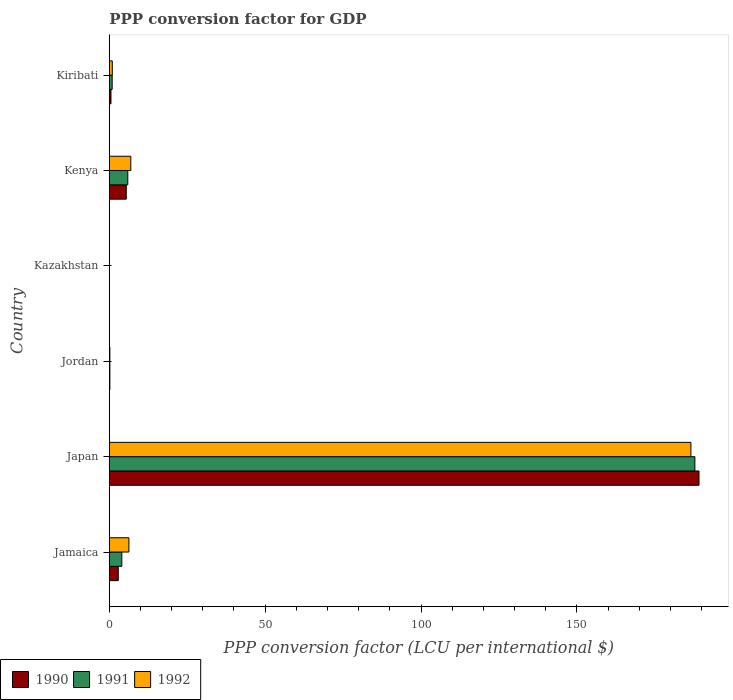How many different coloured bars are there?
Give a very brief answer. 3. How many groups of bars are there?
Provide a short and direct response. 6. Are the number of bars per tick equal to the number of legend labels?
Give a very brief answer. Yes. How many bars are there on the 3rd tick from the top?
Your response must be concise. 3. How many bars are there on the 2nd tick from the bottom?
Make the answer very short. 3. What is the label of the 4th group of bars from the top?
Your answer should be very brief. Jordan. In how many cases, is the number of bars for a given country not equal to the number of legend labels?
Offer a very short reply. 0. What is the PPP conversion factor for GDP in 1990 in Jamaica?
Give a very brief answer. 2.89. Across all countries, what is the maximum PPP conversion factor for GDP in 1990?
Your answer should be compact. 189.17. Across all countries, what is the minimum PPP conversion factor for GDP in 1990?
Make the answer very short. 0. In which country was the PPP conversion factor for GDP in 1992 minimum?
Keep it short and to the point. Kazakhstan. What is the total PPP conversion factor for GDP in 1990 in the graph?
Provide a succinct answer. 198.26. What is the difference between the PPP conversion factor for GDP in 1992 in Kazakhstan and that in Kenya?
Provide a succinct answer. -6.89. What is the difference between the PPP conversion factor for GDP in 1991 in Japan and the PPP conversion factor for GDP in 1992 in Kazakhstan?
Provide a short and direct response. 187.83. What is the average PPP conversion factor for GDP in 1990 per country?
Keep it short and to the point. 33.04. What is the difference between the PPP conversion factor for GDP in 1992 and PPP conversion factor for GDP in 1991 in Jordan?
Provide a short and direct response. 0. What is the ratio of the PPP conversion factor for GDP in 1992 in Jamaica to that in Kenya?
Offer a very short reply. 0.91. What is the difference between the highest and the second highest PPP conversion factor for GDP in 1991?
Keep it short and to the point. 181.91. What is the difference between the highest and the lowest PPP conversion factor for GDP in 1992?
Provide a short and direct response. 186.56. In how many countries, is the PPP conversion factor for GDP in 1991 greater than the average PPP conversion factor for GDP in 1991 taken over all countries?
Your answer should be very brief. 1. Is the sum of the PPP conversion factor for GDP in 1990 in Kazakhstan and Kenya greater than the maximum PPP conversion factor for GDP in 1991 across all countries?
Keep it short and to the point. No. What does the 3rd bar from the top in Kazakhstan represents?
Provide a short and direct response. 1990. What does the 2nd bar from the bottom in Japan represents?
Provide a short and direct response. 1991. How many bars are there?
Give a very brief answer. 18. What is the difference between two consecutive major ticks on the X-axis?
Keep it short and to the point. 50. Are the values on the major ticks of X-axis written in scientific E-notation?
Give a very brief answer. No. Does the graph contain any zero values?
Make the answer very short. No. Does the graph contain grids?
Ensure brevity in your answer.  No. How many legend labels are there?
Provide a succinct answer. 3. What is the title of the graph?
Provide a succinct answer. PPP conversion factor for GDP. Does "1984" appear as one of the legend labels in the graph?
Ensure brevity in your answer.  No. What is the label or title of the X-axis?
Keep it short and to the point. PPP conversion factor (LCU per international $). What is the PPP conversion factor (LCU per international $) of 1990 in Jamaica?
Your response must be concise. 2.89. What is the PPP conversion factor (LCU per international $) of 1991 in Jamaica?
Your answer should be compact. 4.02. What is the PPP conversion factor (LCU per international $) of 1992 in Jamaica?
Make the answer very short. 6.3. What is the PPP conversion factor (LCU per international $) of 1990 in Japan?
Offer a very short reply. 189.17. What is the PPP conversion factor (LCU per international $) in 1991 in Japan?
Give a very brief answer. 187.85. What is the PPP conversion factor (LCU per international $) in 1992 in Japan?
Offer a very short reply. 186.58. What is the PPP conversion factor (LCU per international $) of 1990 in Jordan?
Give a very brief answer. 0.19. What is the PPP conversion factor (LCU per international $) of 1991 in Jordan?
Offer a terse response. 0.19. What is the PPP conversion factor (LCU per international $) in 1992 in Jordan?
Your answer should be very brief. 0.2. What is the PPP conversion factor (LCU per international $) in 1990 in Kazakhstan?
Offer a very short reply. 0. What is the PPP conversion factor (LCU per international $) in 1991 in Kazakhstan?
Offer a very short reply. 0. What is the PPP conversion factor (LCU per international $) of 1992 in Kazakhstan?
Provide a short and direct response. 0.02. What is the PPP conversion factor (LCU per international $) in 1990 in Kenya?
Ensure brevity in your answer.  5.46. What is the PPP conversion factor (LCU per international $) in 1991 in Kenya?
Provide a short and direct response. 5.94. What is the PPP conversion factor (LCU per international $) of 1992 in Kenya?
Offer a terse response. 6.91. What is the PPP conversion factor (LCU per international $) of 1990 in Kiribati?
Provide a succinct answer. 0.55. What is the PPP conversion factor (LCU per international $) in 1991 in Kiribati?
Your response must be concise. 0.93. What is the PPP conversion factor (LCU per international $) in 1992 in Kiribati?
Give a very brief answer. 0.97. Across all countries, what is the maximum PPP conversion factor (LCU per international $) in 1990?
Provide a short and direct response. 189.17. Across all countries, what is the maximum PPP conversion factor (LCU per international $) of 1991?
Make the answer very short. 187.85. Across all countries, what is the maximum PPP conversion factor (LCU per international $) in 1992?
Make the answer very short. 186.58. Across all countries, what is the minimum PPP conversion factor (LCU per international $) in 1990?
Your response must be concise. 0. Across all countries, what is the minimum PPP conversion factor (LCU per international $) of 1991?
Give a very brief answer. 0. Across all countries, what is the minimum PPP conversion factor (LCU per international $) of 1992?
Offer a terse response. 0.02. What is the total PPP conversion factor (LCU per international $) of 1990 in the graph?
Keep it short and to the point. 198.26. What is the total PPP conversion factor (LCU per international $) of 1991 in the graph?
Your response must be concise. 198.94. What is the total PPP conversion factor (LCU per international $) of 1992 in the graph?
Provide a succinct answer. 200.97. What is the difference between the PPP conversion factor (LCU per international $) of 1990 in Jamaica and that in Japan?
Provide a short and direct response. -186.28. What is the difference between the PPP conversion factor (LCU per international $) in 1991 in Jamaica and that in Japan?
Provide a short and direct response. -183.82. What is the difference between the PPP conversion factor (LCU per international $) in 1992 in Jamaica and that in Japan?
Your answer should be very brief. -180.28. What is the difference between the PPP conversion factor (LCU per international $) of 1990 in Jamaica and that in Jordan?
Your answer should be compact. 2.7. What is the difference between the PPP conversion factor (LCU per international $) of 1991 in Jamaica and that in Jordan?
Give a very brief answer. 3.83. What is the difference between the PPP conversion factor (LCU per international $) of 1992 in Jamaica and that in Jordan?
Make the answer very short. 6.1. What is the difference between the PPP conversion factor (LCU per international $) in 1990 in Jamaica and that in Kazakhstan?
Keep it short and to the point. 2.89. What is the difference between the PPP conversion factor (LCU per international $) in 1991 in Jamaica and that in Kazakhstan?
Your answer should be compact. 4.02. What is the difference between the PPP conversion factor (LCU per international $) of 1992 in Jamaica and that in Kazakhstan?
Offer a terse response. 6.28. What is the difference between the PPP conversion factor (LCU per international $) in 1990 in Jamaica and that in Kenya?
Provide a short and direct response. -2.56. What is the difference between the PPP conversion factor (LCU per international $) of 1991 in Jamaica and that in Kenya?
Make the answer very short. -1.92. What is the difference between the PPP conversion factor (LCU per international $) in 1992 in Jamaica and that in Kenya?
Keep it short and to the point. -0.61. What is the difference between the PPP conversion factor (LCU per international $) in 1990 in Jamaica and that in Kiribati?
Make the answer very short. 2.35. What is the difference between the PPP conversion factor (LCU per international $) in 1991 in Jamaica and that in Kiribati?
Provide a succinct answer. 3.09. What is the difference between the PPP conversion factor (LCU per international $) in 1992 in Jamaica and that in Kiribati?
Offer a terse response. 5.33. What is the difference between the PPP conversion factor (LCU per international $) in 1990 in Japan and that in Jordan?
Your answer should be compact. 188.98. What is the difference between the PPP conversion factor (LCU per international $) of 1991 in Japan and that in Jordan?
Offer a very short reply. 187.65. What is the difference between the PPP conversion factor (LCU per international $) of 1992 in Japan and that in Jordan?
Make the answer very short. 186.38. What is the difference between the PPP conversion factor (LCU per international $) in 1990 in Japan and that in Kazakhstan?
Make the answer very short. 189.17. What is the difference between the PPP conversion factor (LCU per international $) in 1991 in Japan and that in Kazakhstan?
Your answer should be very brief. 187.85. What is the difference between the PPP conversion factor (LCU per international $) in 1992 in Japan and that in Kazakhstan?
Provide a short and direct response. 186.56. What is the difference between the PPP conversion factor (LCU per international $) in 1990 in Japan and that in Kenya?
Make the answer very short. 183.72. What is the difference between the PPP conversion factor (LCU per international $) of 1991 in Japan and that in Kenya?
Provide a succinct answer. 181.91. What is the difference between the PPP conversion factor (LCU per international $) of 1992 in Japan and that in Kenya?
Offer a very short reply. 179.67. What is the difference between the PPP conversion factor (LCU per international $) in 1990 in Japan and that in Kiribati?
Your response must be concise. 188.63. What is the difference between the PPP conversion factor (LCU per international $) of 1991 in Japan and that in Kiribati?
Offer a terse response. 186.92. What is the difference between the PPP conversion factor (LCU per international $) of 1992 in Japan and that in Kiribati?
Ensure brevity in your answer.  185.61. What is the difference between the PPP conversion factor (LCU per international $) in 1990 in Jordan and that in Kazakhstan?
Your response must be concise. 0.19. What is the difference between the PPP conversion factor (LCU per international $) of 1991 in Jordan and that in Kazakhstan?
Give a very brief answer. 0.19. What is the difference between the PPP conversion factor (LCU per international $) of 1992 in Jordan and that in Kazakhstan?
Provide a short and direct response. 0.18. What is the difference between the PPP conversion factor (LCU per international $) of 1990 in Jordan and that in Kenya?
Offer a terse response. -5.26. What is the difference between the PPP conversion factor (LCU per international $) of 1991 in Jordan and that in Kenya?
Give a very brief answer. -5.75. What is the difference between the PPP conversion factor (LCU per international $) in 1992 in Jordan and that in Kenya?
Your response must be concise. -6.71. What is the difference between the PPP conversion factor (LCU per international $) of 1990 in Jordan and that in Kiribati?
Give a very brief answer. -0.35. What is the difference between the PPP conversion factor (LCU per international $) in 1991 in Jordan and that in Kiribati?
Give a very brief answer. -0.74. What is the difference between the PPP conversion factor (LCU per international $) in 1992 in Jordan and that in Kiribati?
Offer a very short reply. -0.78. What is the difference between the PPP conversion factor (LCU per international $) of 1990 in Kazakhstan and that in Kenya?
Provide a succinct answer. -5.45. What is the difference between the PPP conversion factor (LCU per international $) in 1991 in Kazakhstan and that in Kenya?
Provide a succinct answer. -5.94. What is the difference between the PPP conversion factor (LCU per international $) of 1992 in Kazakhstan and that in Kenya?
Keep it short and to the point. -6.89. What is the difference between the PPP conversion factor (LCU per international $) of 1990 in Kazakhstan and that in Kiribati?
Give a very brief answer. -0.54. What is the difference between the PPP conversion factor (LCU per international $) of 1991 in Kazakhstan and that in Kiribati?
Your response must be concise. -0.93. What is the difference between the PPP conversion factor (LCU per international $) in 1992 in Kazakhstan and that in Kiribati?
Give a very brief answer. -0.95. What is the difference between the PPP conversion factor (LCU per international $) of 1990 in Kenya and that in Kiribati?
Your answer should be very brief. 4.91. What is the difference between the PPP conversion factor (LCU per international $) in 1991 in Kenya and that in Kiribati?
Provide a succinct answer. 5.01. What is the difference between the PPP conversion factor (LCU per international $) of 1992 in Kenya and that in Kiribati?
Provide a short and direct response. 5.93. What is the difference between the PPP conversion factor (LCU per international $) of 1990 in Jamaica and the PPP conversion factor (LCU per international $) of 1991 in Japan?
Your answer should be very brief. -184.96. What is the difference between the PPP conversion factor (LCU per international $) of 1990 in Jamaica and the PPP conversion factor (LCU per international $) of 1992 in Japan?
Keep it short and to the point. -183.69. What is the difference between the PPP conversion factor (LCU per international $) in 1991 in Jamaica and the PPP conversion factor (LCU per international $) in 1992 in Japan?
Offer a terse response. -182.55. What is the difference between the PPP conversion factor (LCU per international $) of 1990 in Jamaica and the PPP conversion factor (LCU per international $) of 1991 in Jordan?
Provide a succinct answer. 2.7. What is the difference between the PPP conversion factor (LCU per international $) of 1990 in Jamaica and the PPP conversion factor (LCU per international $) of 1992 in Jordan?
Give a very brief answer. 2.7. What is the difference between the PPP conversion factor (LCU per international $) of 1991 in Jamaica and the PPP conversion factor (LCU per international $) of 1992 in Jordan?
Give a very brief answer. 3.83. What is the difference between the PPP conversion factor (LCU per international $) of 1990 in Jamaica and the PPP conversion factor (LCU per international $) of 1991 in Kazakhstan?
Provide a short and direct response. 2.89. What is the difference between the PPP conversion factor (LCU per international $) in 1990 in Jamaica and the PPP conversion factor (LCU per international $) in 1992 in Kazakhstan?
Offer a very short reply. 2.87. What is the difference between the PPP conversion factor (LCU per international $) of 1991 in Jamaica and the PPP conversion factor (LCU per international $) of 1992 in Kazakhstan?
Give a very brief answer. 4. What is the difference between the PPP conversion factor (LCU per international $) in 1990 in Jamaica and the PPP conversion factor (LCU per international $) in 1991 in Kenya?
Give a very brief answer. -3.05. What is the difference between the PPP conversion factor (LCU per international $) in 1990 in Jamaica and the PPP conversion factor (LCU per international $) in 1992 in Kenya?
Offer a terse response. -4.02. What is the difference between the PPP conversion factor (LCU per international $) of 1991 in Jamaica and the PPP conversion factor (LCU per international $) of 1992 in Kenya?
Your answer should be compact. -2.88. What is the difference between the PPP conversion factor (LCU per international $) of 1990 in Jamaica and the PPP conversion factor (LCU per international $) of 1991 in Kiribati?
Ensure brevity in your answer.  1.96. What is the difference between the PPP conversion factor (LCU per international $) in 1990 in Jamaica and the PPP conversion factor (LCU per international $) in 1992 in Kiribati?
Give a very brief answer. 1.92. What is the difference between the PPP conversion factor (LCU per international $) of 1991 in Jamaica and the PPP conversion factor (LCU per international $) of 1992 in Kiribati?
Give a very brief answer. 3.05. What is the difference between the PPP conversion factor (LCU per international $) in 1990 in Japan and the PPP conversion factor (LCU per international $) in 1991 in Jordan?
Your answer should be very brief. 188.98. What is the difference between the PPP conversion factor (LCU per international $) of 1990 in Japan and the PPP conversion factor (LCU per international $) of 1992 in Jordan?
Offer a terse response. 188.98. What is the difference between the PPP conversion factor (LCU per international $) of 1991 in Japan and the PPP conversion factor (LCU per international $) of 1992 in Jordan?
Your answer should be very brief. 187.65. What is the difference between the PPP conversion factor (LCU per international $) in 1990 in Japan and the PPP conversion factor (LCU per international $) in 1991 in Kazakhstan?
Ensure brevity in your answer.  189.17. What is the difference between the PPP conversion factor (LCU per international $) of 1990 in Japan and the PPP conversion factor (LCU per international $) of 1992 in Kazakhstan?
Make the answer very short. 189.15. What is the difference between the PPP conversion factor (LCU per international $) of 1991 in Japan and the PPP conversion factor (LCU per international $) of 1992 in Kazakhstan?
Ensure brevity in your answer.  187.83. What is the difference between the PPP conversion factor (LCU per international $) in 1990 in Japan and the PPP conversion factor (LCU per international $) in 1991 in Kenya?
Make the answer very short. 183.23. What is the difference between the PPP conversion factor (LCU per international $) of 1990 in Japan and the PPP conversion factor (LCU per international $) of 1992 in Kenya?
Keep it short and to the point. 182.27. What is the difference between the PPP conversion factor (LCU per international $) of 1991 in Japan and the PPP conversion factor (LCU per international $) of 1992 in Kenya?
Make the answer very short. 180.94. What is the difference between the PPP conversion factor (LCU per international $) in 1990 in Japan and the PPP conversion factor (LCU per international $) in 1991 in Kiribati?
Your response must be concise. 188.24. What is the difference between the PPP conversion factor (LCU per international $) in 1990 in Japan and the PPP conversion factor (LCU per international $) in 1992 in Kiribati?
Offer a very short reply. 188.2. What is the difference between the PPP conversion factor (LCU per international $) in 1991 in Japan and the PPP conversion factor (LCU per international $) in 1992 in Kiribati?
Ensure brevity in your answer.  186.88. What is the difference between the PPP conversion factor (LCU per international $) in 1990 in Jordan and the PPP conversion factor (LCU per international $) in 1991 in Kazakhstan?
Keep it short and to the point. 0.19. What is the difference between the PPP conversion factor (LCU per international $) in 1990 in Jordan and the PPP conversion factor (LCU per international $) in 1992 in Kazakhstan?
Provide a succinct answer. 0.17. What is the difference between the PPP conversion factor (LCU per international $) in 1991 in Jordan and the PPP conversion factor (LCU per international $) in 1992 in Kazakhstan?
Provide a succinct answer. 0.17. What is the difference between the PPP conversion factor (LCU per international $) in 1990 in Jordan and the PPP conversion factor (LCU per international $) in 1991 in Kenya?
Provide a short and direct response. -5.75. What is the difference between the PPP conversion factor (LCU per international $) in 1990 in Jordan and the PPP conversion factor (LCU per international $) in 1992 in Kenya?
Offer a very short reply. -6.72. What is the difference between the PPP conversion factor (LCU per international $) of 1991 in Jordan and the PPP conversion factor (LCU per international $) of 1992 in Kenya?
Give a very brief answer. -6.71. What is the difference between the PPP conversion factor (LCU per international $) of 1990 in Jordan and the PPP conversion factor (LCU per international $) of 1991 in Kiribati?
Keep it short and to the point. -0.74. What is the difference between the PPP conversion factor (LCU per international $) of 1990 in Jordan and the PPP conversion factor (LCU per international $) of 1992 in Kiribati?
Offer a very short reply. -0.78. What is the difference between the PPP conversion factor (LCU per international $) in 1991 in Jordan and the PPP conversion factor (LCU per international $) in 1992 in Kiribati?
Give a very brief answer. -0.78. What is the difference between the PPP conversion factor (LCU per international $) in 1990 in Kazakhstan and the PPP conversion factor (LCU per international $) in 1991 in Kenya?
Your answer should be compact. -5.94. What is the difference between the PPP conversion factor (LCU per international $) in 1990 in Kazakhstan and the PPP conversion factor (LCU per international $) in 1992 in Kenya?
Offer a very short reply. -6.91. What is the difference between the PPP conversion factor (LCU per international $) of 1991 in Kazakhstan and the PPP conversion factor (LCU per international $) of 1992 in Kenya?
Ensure brevity in your answer.  -6.91. What is the difference between the PPP conversion factor (LCU per international $) in 1990 in Kazakhstan and the PPP conversion factor (LCU per international $) in 1991 in Kiribati?
Your answer should be compact. -0.93. What is the difference between the PPP conversion factor (LCU per international $) in 1990 in Kazakhstan and the PPP conversion factor (LCU per international $) in 1992 in Kiribati?
Offer a very short reply. -0.97. What is the difference between the PPP conversion factor (LCU per international $) in 1991 in Kazakhstan and the PPP conversion factor (LCU per international $) in 1992 in Kiribati?
Keep it short and to the point. -0.97. What is the difference between the PPP conversion factor (LCU per international $) in 1990 in Kenya and the PPP conversion factor (LCU per international $) in 1991 in Kiribati?
Make the answer very short. 4.53. What is the difference between the PPP conversion factor (LCU per international $) of 1990 in Kenya and the PPP conversion factor (LCU per international $) of 1992 in Kiribati?
Your response must be concise. 4.48. What is the difference between the PPP conversion factor (LCU per international $) in 1991 in Kenya and the PPP conversion factor (LCU per international $) in 1992 in Kiribati?
Your answer should be very brief. 4.97. What is the average PPP conversion factor (LCU per international $) of 1990 per country?
Your answer should be very brief. 33.04. What is the average PPP conversion factor (LCU per international $) of 1991 per country?
Offer a terse response. 33.16. What is the average PPP conversion factor (LCU per international $) of 1992 per country?
Provide a short and direct response. 33.5. What is the difference between the PPP conversion factor (LCU per international $) of 1990 and PPP conversion factor (LCU per international $) of 1991 in Jamaica?
Provide a short and direct response. -1.13. What is the difference between the PPP conversion factor (LCU per international $) of 1990 and PPP conversion factor (LCU per international $) of 1992 in Jamaica?
Your answer should be very brief. -3.41. What is the difference between the PPP conversion factor (LCU per international $) in 1991 and PPP conversion factor (LCU per international $) in 1992 in Jamaica?
Offer a very short reply. -2.27. What is the difference between the PPP conversion factor (LCU per international $) of 1990 and PPP conversion factor (LCU per international $) of 1991 in Japan?
Your answer should be very brief. 1.32. What is the difference between the PPP conversion factor (LCU per international $) in 1990 and PPP conversion factor (LCU per international $) in 1992 in Japan?
Provide a short and direct response. 2.59. What is the difference between the PPP conversion factor (LCU per international $) in 1991 and PPP conversion factor (LCU per international $) in 1992 in Japan?
Ensure brevity in your answer.  1.27. What is the difference between the PPP conversion factor (LCU per international $) of 1990 and PPP conversion factor (LCU per international $) of 1991 in Jordan?
Keep it short and to the point. -0. What is the difference between the PPP conversion factor (LCU per international $) of 1990 and PPP conversion factor (LCU per international $) of 1992 in Jordan?
Give a very brief answer. -0. What is the difference between the PPP conversion factor (LCU per international $) of 1991 and PPP conversion factor (LCU per international $) of 1992 in Jordan?
Keep it short and to the point. -0. What is the difference between the PPP conversion factor (LCU per international $) of 1990 and PPP conversion factor (LCU per international $) of 1991 in Kazakhstan?
Ensure brevity in your answer.  -0. What is the difference between the PPP conversion factor (LCU per international $) in 1990 and PPP conversion factor (LCU per international $) in 1992 in Kazakhstan?
Make the answer very short. -0.02. What is the difference between the PPP conversion factor (LCU per international $) in 1991 and PPP conversion factor (LCU per international $) in 1992 in Kazakhstan?
Offer a very short reply. -0.02. What is the difference between the PPP conversion factor (LCU per international $) of 1990 and PPP conversion factor (LCU per international $) of 1991 in Kenya?
Your response must be concise. -0.49. What is the difference between the PPP conversion factor (LCU per international $) in 1990 and PPP conversion factor (LCU per international $) in 1992 in Kenya?
Offer a very short reply. -1.45. What is the difference between the PPP conversion factor (LCU per international $) of 1991 and PPP conversion factor (LCU per international $) of 1992 in Kenya?
Give a very brief answer. -0.97. What is the difference between the PPP conversion factor (LCU per international $) of 1990 and PPP conversion factor (LCU per international $) of 1991 in Kiribati?
Offer a terse response. -0.38. What is the difference between the PPP conversion factor (LCU per international $) of 1990 and PPP conversion factor (LCU per international $) of 1992 in Kiribati?
Offer a very short reply. -0.43. What is the difference between the PPP conversion factor (LCU per international $) of 1991 and PPP conversion factor (LCU per international $) of 1992 in Kiribati?
Your response must be concise. -0.04. What is the ratio of the PPP conversion factor (LCU per international $) of 1990 in Jamaica to that in Japan?
Your answer should be compact. 0.02. What is the ratio of the PPP conversion factor (LCU per international $) in 1991 in Jamaica to that in Japan?
Provide a succinct answer. 0.02. What is the ratio of the PPP conversion factor (LCU per international $) of 1992 in Jamaica to that in Japan?
Keep it short and to the point. 0.03. What is the ratio of the PPP conversion factor (LCU per international $) in 1990 in Jamaica to that in Jordan?
Ensure brevity in your answer.  15.14. What is the ratio of the PPP conversion factor (LCU per international $) of 1991 in Jamaica to that in Jordan?
Offer a terse response. 20.7. What is the ratio of the PPP conversion factor (LCU per international $) in 1992 in Jamaica to that in Jordan?
Provide a short and direct response. 32.21. What is the ratio of the PPP conversion factor (LCU per international $) of 1990 in Jamaica to that in Kazakhstan?
Offer a very short reply. 4194.75. What is the ratio of the PPP conversion factor (LCU per international $) in 1991 in Jamaica to that in Kazakhstan?
Offer a terse response. 3072.89. What is the ratio of the PPP conversion factor (LCU per international $) of 1992 in Jamaica to that in Kazakhstan?
Offer a very short reply. 312.79. What is the ratio of the PPP conversion factor (LCU per international $) of 1990 in Jamaica to that in Kenya?
Provide a succinct answer. 0.53. What is the ratio of the PPP conversion factor (LCU per international $) in 1991 in Jamaica to that in Kenya?
Your answer should be very brief. 0.68. What is the ratio of the PPP conversion factor (LCU per international $) in 1992 in Jamaica to that in Kenya?
Provide a succinct answer. 0.91. What is the ratio of the PPP conversion factor (LCU per international $) of 1990 in Jamaica to that in Kiribati?
Provide a short and direct response. 5.3. What is the ratio of the PPP conversion factor (LCU per international $) of 1991 in Jamaica to that in Kiribati?
Your answer should be very brief. 4.33. What is the ratio of the PPP conversion factor (LCU per international $) of 1992 in Jamaica to that in Kiribati?
Offer a very short reply. 6.48. What is the ratio of the PPP conversion factor (LCU per international $) in 1990 in Japan to that in Jordan?
Offer a terse response. 990.73. What is the ratio of the PPP conversion factor (LCU per international $) in 1991 in Japan to that in Jordan?
Your answer should be very brief. 966.15. What is the ratio of the PPP conversion factor (LCU per international $) in 1992 in Japan to that in Jordan?
Provide a succinct answer. 954.23. What is the ratio of the PPP conversion factor (LCU per international $) in 1990 in Japan to that in Kazakhstan?
Offer a terse response. 2.74e+05. What is the ratio of the PPP conversion factor (LCU per international $) of 1991 in Japan to that in Kazakhstan?
Make the answer very short. 1.43e+05. What is the ratio of the PPP conversion factor (LCU per international $) of 1992 in Japan to that in Kazakhstan?
Your answer should be very brief. 9266.86. What is the ratio of the PPP conversion factor (LCU per international $) in 1990 in Japan to that in Kenya?
Your response must be concise. 34.67. What is the ratio of the PPP conversion factor (LCU per international $) of 1991 in Japan to that in Kenya?
Keep it short and to the point. 31.62. What is the ratio of the PPP conversion factor (LCU per international $) in 1992 in Japan to that in Kenya?
Ensure brevity in your answer.  27.01. What is the ratio of the PPP conversion factor (LCU per international $) of 1990 in Japan to that in Kiribati?
Provide a short and direct response. 346.76. What is the ratio of the PPP conversion factor (LCU per international $) in 1991 in Japan to that in Kiribati?
Your response must be concise. 201.95. What is the ratio of the PPP conversion factor (LCU per international $) in 1992 in Japan to that in Kiribati?
Provide a short and direct response. 191.86. What is the ratio of the PPP conversion factor (LCU per international $) of 1990 in Jordan to that in Kazakhstan?
Your answer should be very brief. 277.03. What is the ratio of the PPP conversion factor (LCU per international $) of 1991 in Jordan to that in Kazakhstan?
Keep it short and to the point. 148.44. What is the ratio of the PPP conversion factor (LCU per international $) of 1992 in Jordan to that in Kazakhstan?
Ensure brevity in your answer.  9.71. What is the ratio of the PPP conversion factor (LCU per international $) of 1990 in Jordan to that in Kenya?
Give a very brief answer. 0.04. What is the ratio of the PPP conversion factor (LCU per international $) in 1991 in Jordan to that in Kenya?
Provide a short and direct response. 0.03. What is the ratio of the PPP conversion factor (LCU per international $) in 1992 in Jordan to that in Kenya?
Your answer should be compact. 0.03. What is the ratio of the PPP conversion factor (LCU per international $) in 1990 in Jordan to that in Kiribati?
Offer a very short reply. 0.35. What is the ratio of the PPP conversion factor (LCU per international $) of 1991 in Jordan to that in Kiribati?
Ensure brevity in your answer.  0.21. What is the ratio of the PPP conversion factor (LCU per international $) in 1992 in Jordan to that in Kiribati?
Provide a succinct answer. 0.2. What is the ratio of the PPP conversion factor (LCU per international $) of 1991 in Kazakhstan to that in Kenya?
Your answer should be very brief. 0. What is the ratio of the PPP conversion factor (LCU per international $) of 1992 in Kazakhstan to that in Kenya?
Give a very brief answer. 0. What is the ratio of the PPP conversion factor (LCU per international $) of 1990 in Kazakhstan to that in Kiribati?
Offer a terse response. 0. What is the ratio of the PPP conversion factor (LCU per international $) of 1991 in Kazakhstan to that in Kiribati?
Your answer should be compact. 0. What is the ratio of the PPP conversion factor (LCU per international $) in 1992 in Kazakhstan to that in Kiribati?
Keep it short and to the point. 0.02. What is the ratio of the PPP conversion factor (LCU per international $) of 1990 in Kenya to that in Kiribati?
Make the answer very short. 10. What is the ratio of the PPP conversion factor (LCU per international $) in 1991 in Kenya to that in Kiribati?
Your answer should be very brief. 6.39. What is the ratio of the PPP conversion factor (LCU per international $) of 1992 in Kenya to that in Kiribati?
Make the answer very short. 7.1. What is the difference between the highest and the second highest PPP conversion factor (LCU per international $) of 1990?
Keep it short and to the point. 183.72. What is the difference between the highest and the second highest PPP conversion factor (LCU per international $) of 1991?
Give a very brief answer. 181.91. What is the difference between the highest and the second highest PPP conversion factor (LCU per international $) of 1992?
Make the answer very short. 179.67. What is the difference between the highest and the lowest PPP conversion factor (LCU per international $) in 1990?
Provide a short and direct response. 189.17. What is the difference between the highest and the lowest PPP conversion factor (LCU per international $) in 1991?
Provide a short and direct response. 187.85. What is the difference between the highest and the lowest PPP conversion factor (LCU per international $) in 1992?
Offer a very short reply. 186.56. 